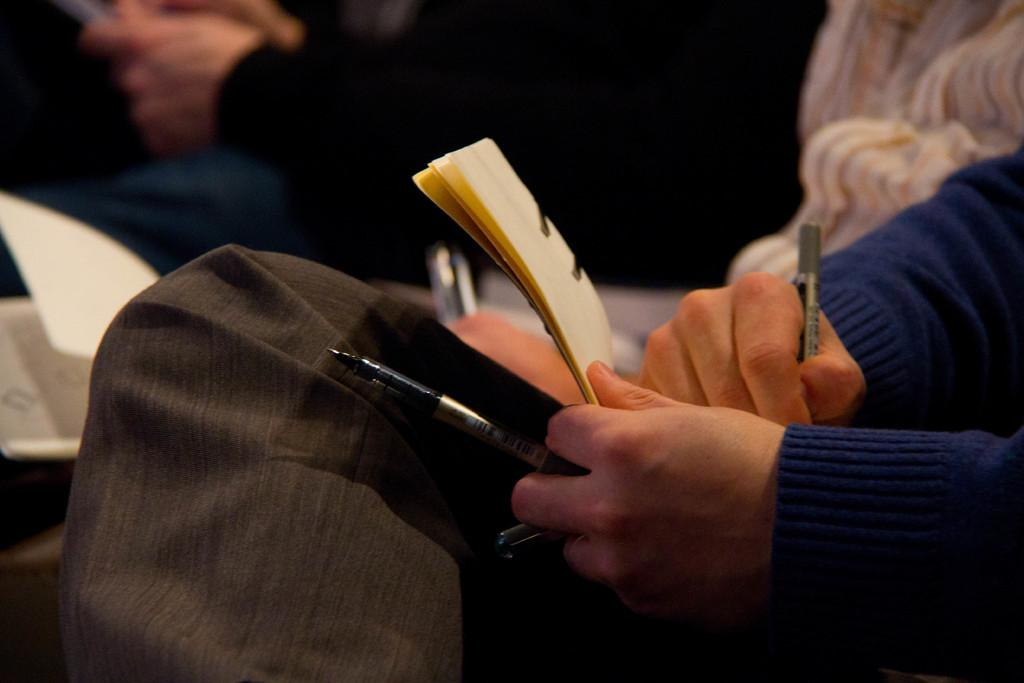Who or what can be seen in the image? There are people in the image. What is one of the people doing in the image? A person is sitting in the image. What is the sitting person holding? The sitting person is holding pens. What else can be seen in the image besides people? There is a book in the image. How many birds are visible in the image? There are no birds present in the image. What type of bird is sitting on the person's shoulder in the image? There is no bird present in the image, so it is not possible to determine the type of bird. 